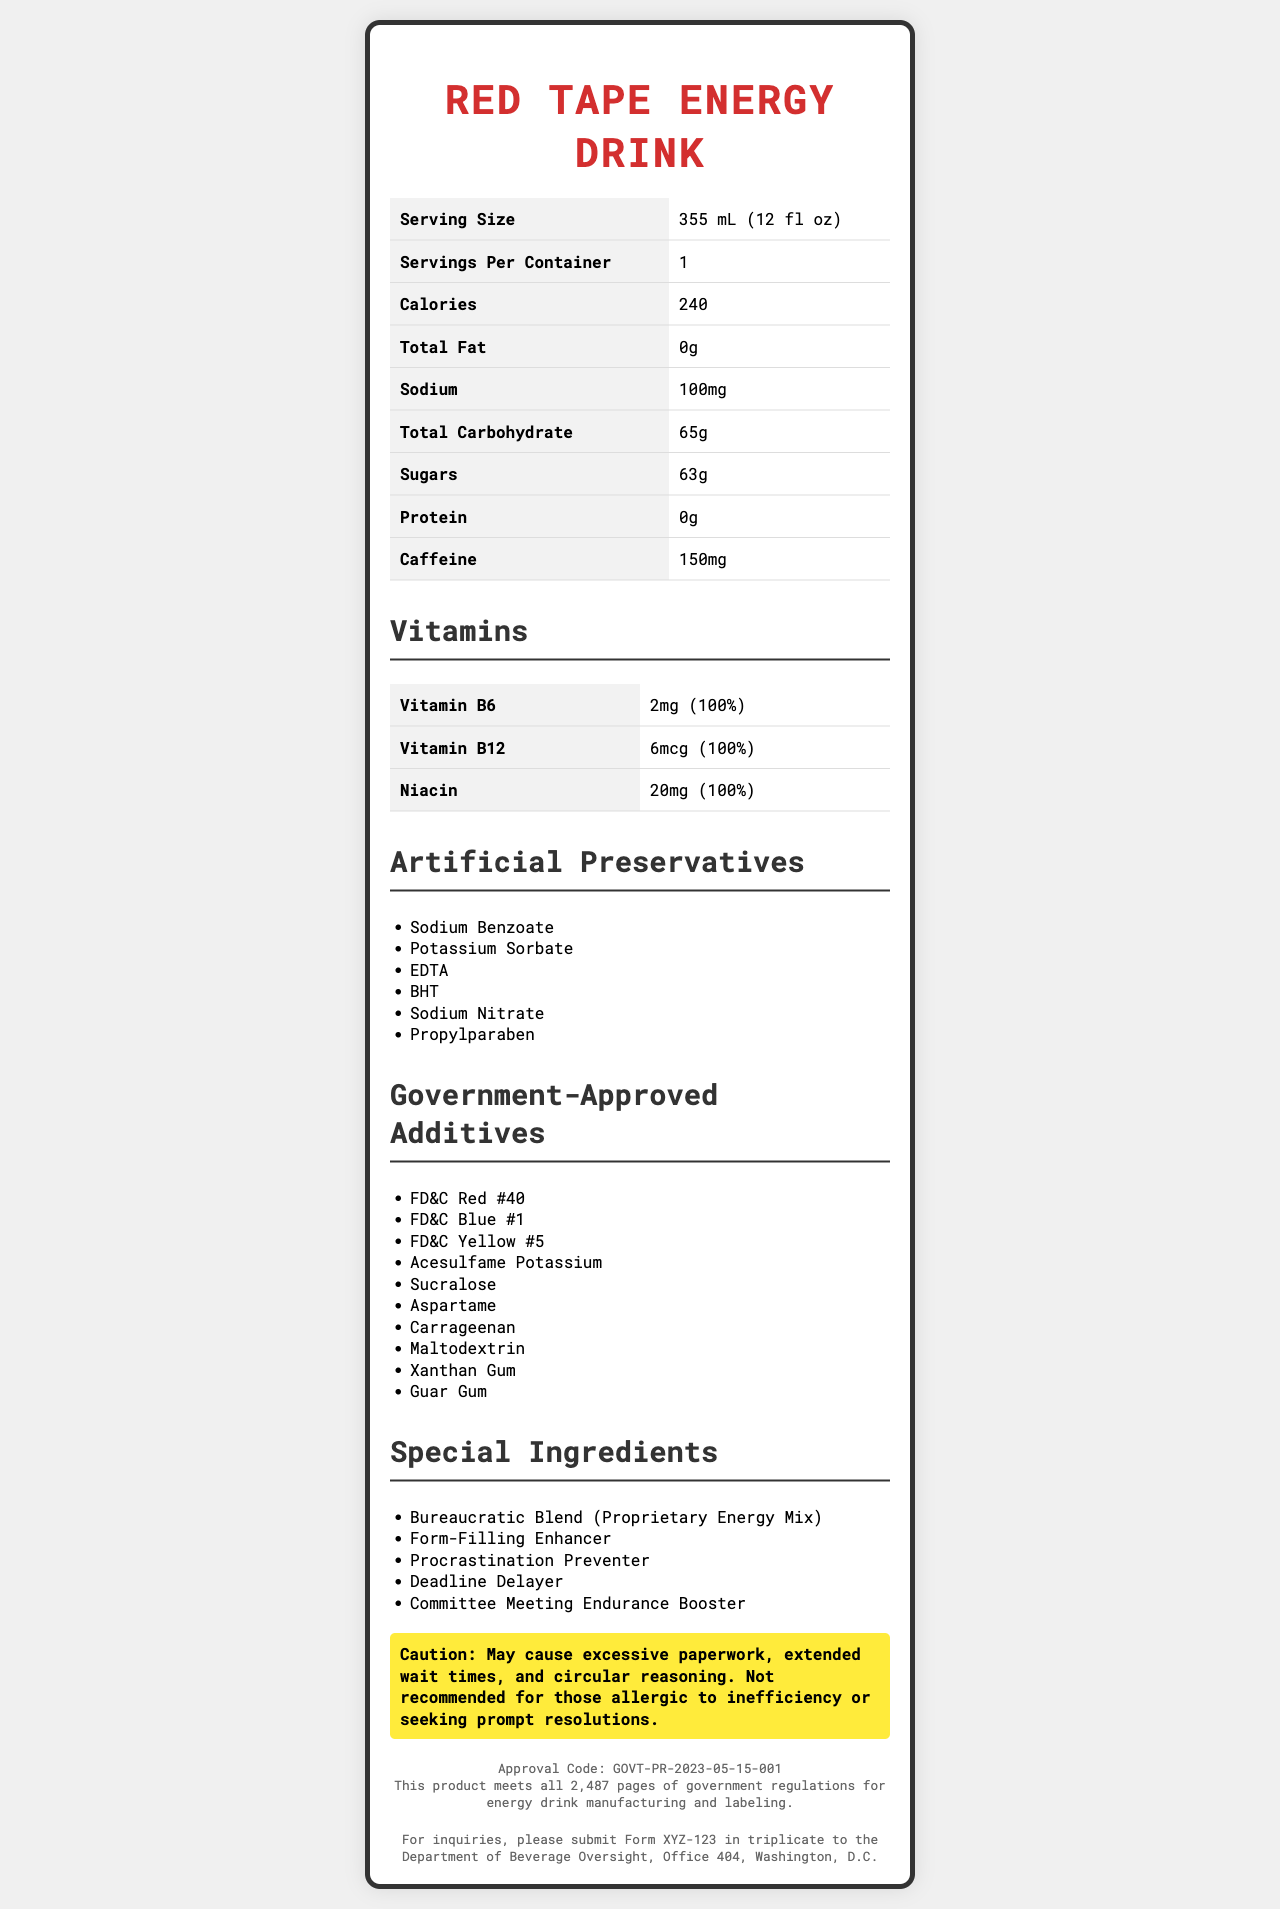what is the serving size of Red Tape Energy Drink? The serving size is clearly listed in the table under "Serving Size".
Answer: 355 mL (12 fl oz) how many calories are in one serving of Red Tape Energy Drink? The calories per serving are listed in the nutrition facts table as 240.
Answer: 240 what is the sodium content in the drink? The sodium content is listed in the nutrition facts table as 100mg.
Answer: 100mg what vitamins does the Red Tape Energy Drink contain? The vitamins section lists Vitamin B6, Vitamin B12, and Niacin.
Answer: Vitamin B6, Vitamin B12, Niacin name three artificial preservatives found in the drink The artificial preservatives section lists several preservatives including Sodium Benzoate, Potassium Sorbate, and EDTA.
Answer: Sodium Benzoate, Potassium Sorbate, EDTA which of the following is a special ingredient of Red Tape Energy Drink? 
A. Vitamin A
B. Procrastination Preventer
C. Calcium
D. Iron In the special ingredients section, "Procrastination Preventer" is listed, whereas the other options are not mentioned.
Answer: B which of the following government-approved additives is NOT present in Red Tape Energy Drink? 
A. FD&C Blue #1
B. Guar Gum
C. Sodium Benzoate
D. Acesulfame Potassium Sodium Benzoate is an artificial preservative, not a government-approved additive.
Answer: C does the Red Tape Energy Drink contain protein? The nutrition facts clearly state that the drink contains 0g of protein.
Answer: No does the document provide the exact approval code for the Red Tape Energy Drink? The approval code is listed as GOVT-PR-2023-05-15-001.
Answer: Yes summarize the main idea of the document The document contains an extensive list of nutritional information, artificial preservatives, government-approved additives, and special ingredients, alongside a satirical warning and compliance details.
Answer: The document provides detailed nutrition facts and ingredients for Red Tape Energy Drink, emphasizing its artificial preservatives, government-approved additives, and special ingredients with a humorous warning about potential bureaucratic side effects. how many pages of government regulations does the Red Tape Energy Drink meet? The document states that it meets all 2,487 pages of government regulations for energy drink manufacturing and labeling.
Answer: 2,487 pages what is the total carbohydrate content in one serving of the drink? The total carbohydrate content per serving is listed in the nutrition facts table as 65g.
Answer: 65g what specialty ingredient in the drink might enhance form-filling abilities? The special ingredients section lists "Form-Filling Enhancer".
Answer: Form-Filling Enhancer which vitamin has the highest daily value percentage in one serving of the drink? Each of the listed vitamins in the document has a daily value percentage of 100%.
Answer: All listed vitamins (Vitamin B6, Vitamin B12, Niacin) have 100% daily value what is the contact format for inquiries regarding the Red Tape Energy Drink? The contact information section instructs to submit Form XYZ-123 in triplicate to the Department of Beverage Oversight.
Answer: Submit Form XYZ-123 in triplicate are there any instructions on how to consume the Red Tape Energy Drink? The document does not provide any instructions on how to consume the drink.
Answer: Not enough information 